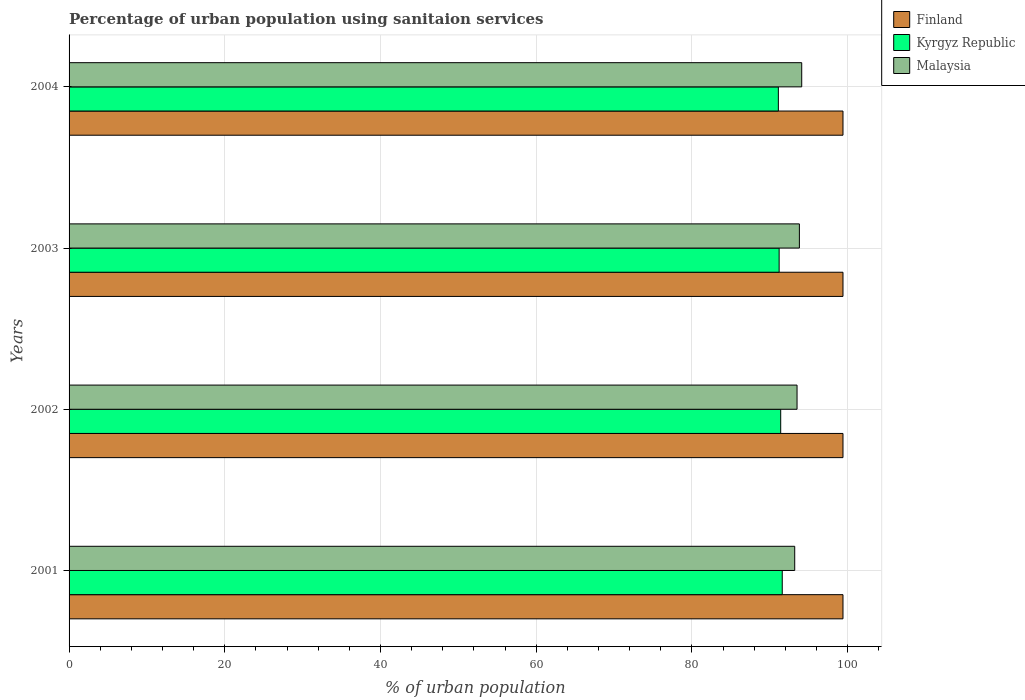How many groups of bars are there?
Your answer should be very brief. 4. Are the number of bars per tick equal to the number of legend labels?
Give a very brief answer. Yes. Are the number of bars on each tick of the Y-axis equal?
Ensure brevity in your answer.  Yes. How many bars are there on the 1st tick from the top?
Your answer should be very brief. 3. How many bars are there on the 3rd tick from the bottom?
Your answer should be very brief. 3. What is the percentage of urban population using sanitaion services in Finland in 2002?
Your response must be concise. 99.4. Across all years, what is the maximum percentage of urban population using sanitaion services in Malaysia?
Give a very brief answer. 94.1. Across all years, what is the minimum percentage of urban population using sanitaion services in Kyrgyz Republic?
Offer a terse response. 91.1. In which year was the percentage of urban population using sanitaion services in Finland minimum?
Provide a succinct answer. 2001. What is the total percentage of urban population using sanitaion services in Kyrgyz Republic in the graph?
Provide a succinct answer. 365.3. What is the difference between the percentage of urban population using sanitaion services in Malaysia in 2001 and that in 2003?
Offer a very short reply. -0.6. What is the difference between the percentage of urban population using sanitaion services in Kyrgyz Republic in 2001 and the percentage of urban population using sanitaion services in Malaysia in 2003?
Offer a terse response. -2.2. What is the average percentage of urban population using sanitaion services in Kyrgyz Republic per year?
Provide a short and direct response. 91.32. In the year 2002, what is the difference between the percentage of urban population using sanitaion services in Kyrgyz Republic and percentage of urban population using sanitaion services in Malaysia?
Give a very brief answer. -2.1. What is the ratio of the percentage of urban population using sanitaion services in Kyrgyz Republic in 2001 to that in 2002?
Your answer should be very brief. 1. Is the percentage of urban population using sanitaion services in Malaysia in 2003 less than that in 2004?
Provide a short and direct response. Yes. Is the difference between the percentage of urban population using sanitaion services in Kyrgyz Republic in 2002 and 2004 greater than the difference between the percentage of urban population using sanitaion services in Malaysia in 2002 and 2004?
Offer a terse response. Yes. What is the difference between the highest and the second highest percentage of urban population using sanitaion services in Malaysia?
Your response must be concise. 0.3. What is the difference between the highest and the lowest percentage of urban population using sanitaion services in Kyrgyz Republic?
Offer a terse response. 0.5. Is the sum of the percentage of urban population using sanitaion services in Finland in 2003 and 2004 greater than the maximum percentage of urban population using sanitaion services in Malaysia across all years?
Ensure brevity in your answer.  Yes. What does the 2nd bar from the top in 2003 represents?
Give a very brief answer. Kyrgyz Republic. What does the 2nd bar from the bottom in 2004 represents?
Provide a short and direct response. Kyrgyz Republic. Are all the bars in the graph horizontal?
Offer a very short reply. Yes. Are the values on the major ticks of X-axis written in scientific E-notation?
Offer a very short reply. No. Does the graph contain any zero values?
Offer a terse response. No. Does the graph contain grids?
Keep it short and to the point. Yes. Where does the legend appear in the graph?
Keep it short and to the point. Top right. What is the title of the graph?
Your answer should be very brief. Percentage of urban population using sanitaion services. Does "Hong Kong" appear as one of the legend labels in the graph?
Keep it short and to the point. No. What is the label or title of the X-axis?
Give a very brief answer. % of urban population. What is the label or title of the Y-axis?
Offer a very short reply. Years. What is the % of urban population in Finland in 2001?
Ensure brevity in your answer.  99.4. What is the % of urban population of Kyrgyz Republic in 2001?
Keep it short and to the point. 91.6. What is the % of urban population in Malaysia in 2001?
Offer a very short reply. 93.2. What is the % of urban population in Finland in 2002?
Give a very brief answer. 99.4. What is the % of urban population in Kyrgyz Republic in 2002?
Offer a very short reply. 91.4. What is the % of urban population in Malaysia in 2002?
Offer a terse response. 93.5. What is the % of urban population of Finland in 2003?
Provide a succinct answer. 99.4. What is the % of urban population of Kyrgyz Republic in 2003?
Your answer should be very brief. 91.2. What is the % of urban population of Malaysia in 2003?
Provide a short and direct response. 93.8. What is the % of urban population of Finland in 2004?
Offer a very short reply. 99.4. What is the % of urban population in Kyrgyz Republic in 2004?
Give a very brief answer. 91.1. What is the % of urban population in Malaysia in 2004?
Offer a very short reply. 94.1. Across all years, what is the maximum % of urban population in Finland?
Offer a very short reply. 99.4. Across all years, what is the maximum % of urban population of Kyrgyz Republic?
Offer a terse response. 91.6. Across all years, what is the maximum % of urban population of Malaysia?
Your response must be concise. 94.1. Across all years, what is the minimum % of urban population in Finland?
Your answer should be compact. 99.4. Across all years, what is the minimum % of urban population of Kyrgyz Republic?
Provide a short and direct response. 91.1. Across all years, what is the minimum % of urban population of Malaysia?
Provide a succinct answer. 93.2. What is the total % of urban population of Finland in the graph?
Your response must be concise. 397.6. What is the total % of urban population of Kyrgyz Republic in the graph?
Your response must be concise. 365.3. What is the total % of urban population of Malaysia in the graph?
Keep it short and to the point. 374.6. What is the difference between the % of urban population in Finland in 2001 and that in 2002?
Ensure brevity in your answer.  0. What is the difference between the % of urban population of Kyrgyz Republic in 2001 and that in 2002?
Provide a short and direct response. 0.2. What is the difference between the % of urban population of Malaysia in 2001 and that in 2002?
Your response must be concise. -0.3. What is the difference between the % of urban population in Kyrgyz Republic in 2001 and that in 2003?
Provide a succinct answer. 0.4. What is the difference between the % of urban population in Malaysia in 2001 and that in 2003?
Your response must be concise. -0.6. What is the difference between the % of urban population of Finland in 2001 and that in 2004?
Your response must be concise. 0. What is the difference between the % of urban population of Kyrgyz Republic in 2002 and that in 2003?
Provide a succinct answer. 0.2. What is the difference between the % of urban population of Finland in 2002 and that in 2004?
Your answer should be compact. 0. What is the difference between the % of urban population of Kyrgyz Republic in 2002 and that in 2004?
Your answer should be very brief. 0.3. What is the difference between the % of urban population in Finland in 2003 and that in 2004?
Give a very brief answer. 0. What is the difference between the % of urban population in Kyrgyz Republic in 2001 and the % of urban population in Malaysia in 2002?
Offer a terse response. -1.9. What is the difference between the % of urban population of Finland in 2001 and the % of urban population of Kyrgyz Republic in 2004?
Provide a short and direct response. 8.3. What is the difference between the % of urban population of Kyrgyz Republic in 2001 and the % of urban population of Malaysia in 2004?
Provide a succinct answer. -2.5. What is the difference between the % of urban population of Finland in 2002 and the % of urban population of Malaysia in 2003?
Keep it short and to the point. 5.6. What is the difference between the % of urban population in Finland in 2002 and the % of urban population in Kyrgyz Republic in 2004?
Give a very brief answer. 8.3. What is the average % of urban population of Finland per year?
Keep it short and to the point. 99.4. What is the average % of urban population in Kyrgyz Republic per year?
Offer a very short reply. 91.33. What is the average % of urban population of Malaysia per year?
Ensure brevity in your answer.  93.65. In the year 2001, what is the difference between the % of urban population in Finland and % of urban population in Malaysia?
Your answer should be very brief. 6.2. In the year 2002, what is the difference between the % of urban population in Finland and % of urban population in Kyrgyz Republic?
Give a very brief answer. 8. In the year 2002, what is the difference between the % of urban population of Finland and % of urban population of Malaysia?
Give a very brief answer. 5.9. In the year 2004, what is the difference between the % of urban population in Finland and % of urban population in Kyrgyz Republic?
Offer a very short reply. 8.3. In the year 2004, what is the difference between the % of urban population of Kyrgyz Republic and % of urban population of Malaysia?
Keep it short and to the point. -3. What is the ratio of the % of urban population of Finland in 2001 to that in 2002?
Provide a succinct answer. 1. What is the ratio of the % of urban population in Finland in 2001 to that in 2003?
Keep it short and to the point. 1. What is the ratio of the % of urban population in Finland in 2001 to that in 2004?
Your answer should be compact. 1. What is the ratio of the % of urban population in Kyrgyz Republic in 2001 to that in 2004?
Ensure brevity in your answer.  1.01. What is the ratio of the % of urban population in Malaysia in 2001 to that in 2004?
Give a very brief answer. 0.99. What is the ratio of the % of urban population of Finland in 2002 to that in 2003?
Your response must be concise. 1. What is the ratio of the % of urban population in Malaysia in 2002 to that in 2003?
Your answer should be compact. 1. What is the ratio of the % of urban population of Kyrgyz Republic in 2002 to that in 2004?
Offer a terse response. 1. What is the ratio of the % of urban population of Malaysia in 2002 to that in 2004?
Offer a terse response. 0.99. What is the ratio of the % of urban population of Kyrgyz Republic in 2003 to that in 2004?
Your answer should be very brief. 1. What is the difference between the highest and the second highest % of urban population of Kyrgyz Republic?
Provide a short and direct response. 0.2. What is the difference between the highest and the lowest % of urban population in Kyrgyz Republic?
Ensure brevity in your answer.  0.5. What is the difference between the highest and the lowest % of urban population of Malaysia?
Make the answer very short. 0.9. 